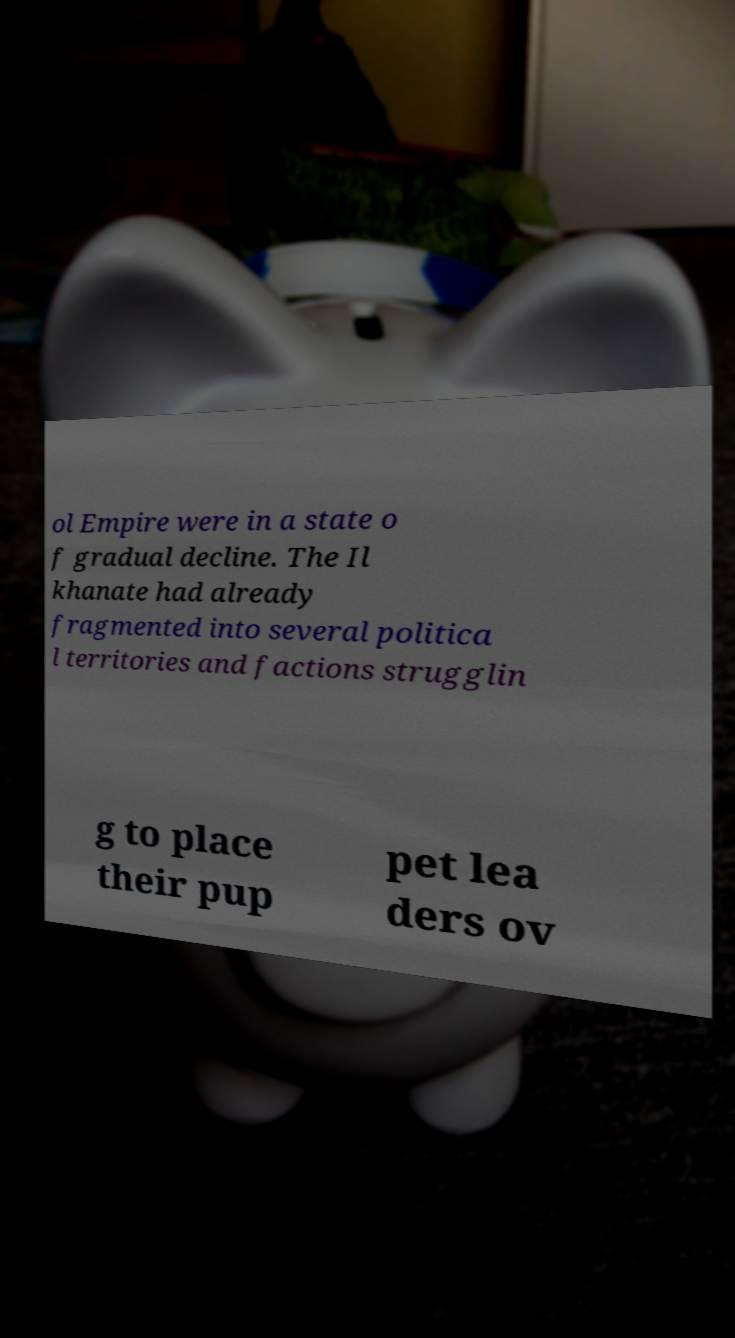Could you extract and type out the text from this image? ol Empire were in a state o f gradual decline. The Il khanate had already fragmented into several politica l territories and factions strugglin g to place their pup pet lea ders ov 